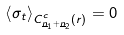Convert formula to latex. <formula><loc_0><loc_0><loc_500><loc_500>\left \langle \sigma _ { t } \right \rangle _ { C ^ { c } _ { \underline { n } _ { 1 } + \underline { n } _ { 2 } } ( r ) } = 0</formula> 